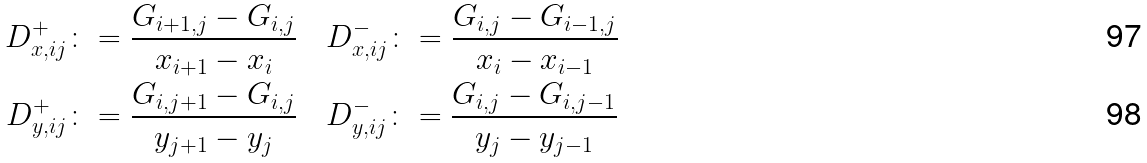Convert formula to latex. <formula><loc_0><loc_0><loc_500><loc_500>D ^ { + } _ { x , i j } & \colon = \frac { G _ { i + 1 , j } - G _ { i , j } } { x _ { i + 1 } - x _ { i } } \quad D ^ { - } _ { x , i j } \colon = \frac { G _ { i , j } - G _ { i - 1 , j } } { x _ { i } - x _ { i - 1 } } \\ D ^ { + } _ { y , i j } & \colon = \frac { G _ { i , j + 1 } - G _ { i , j } } { y _ { j + 1 } - y _ { j } } \quad D ^ { - } _ { y , i j } \colon = \frac { G _ { i , j } - G _ { i , j - 1 } } { y _ { j } - y _ { j - 1 } }</formula> 